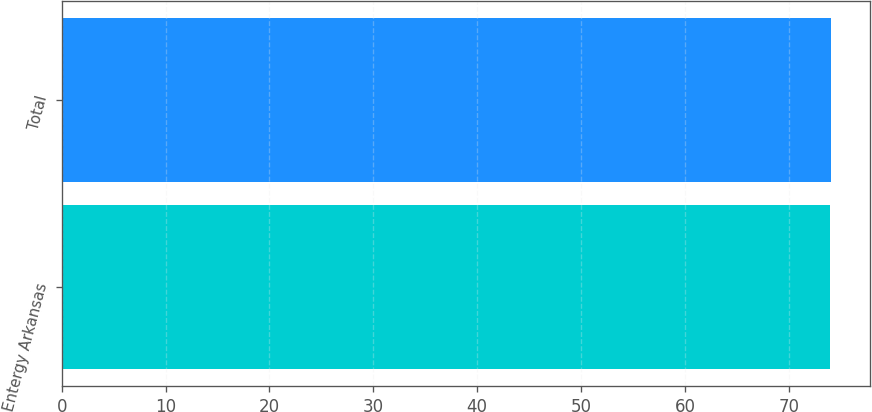Convert chart. <chart><loc_0><loc_0><loc_500><loc_500><bar_chart><fcel>Entergy Arkansas<fcel>Total<nl><fcel>74<fcel>74.1<nl></chart> 